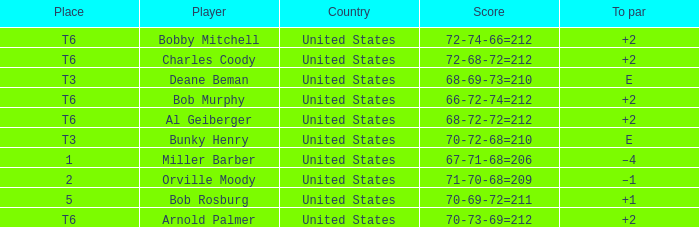Who is the player with a t6 place and a 72-68-72=212 score? Charles Coody. 